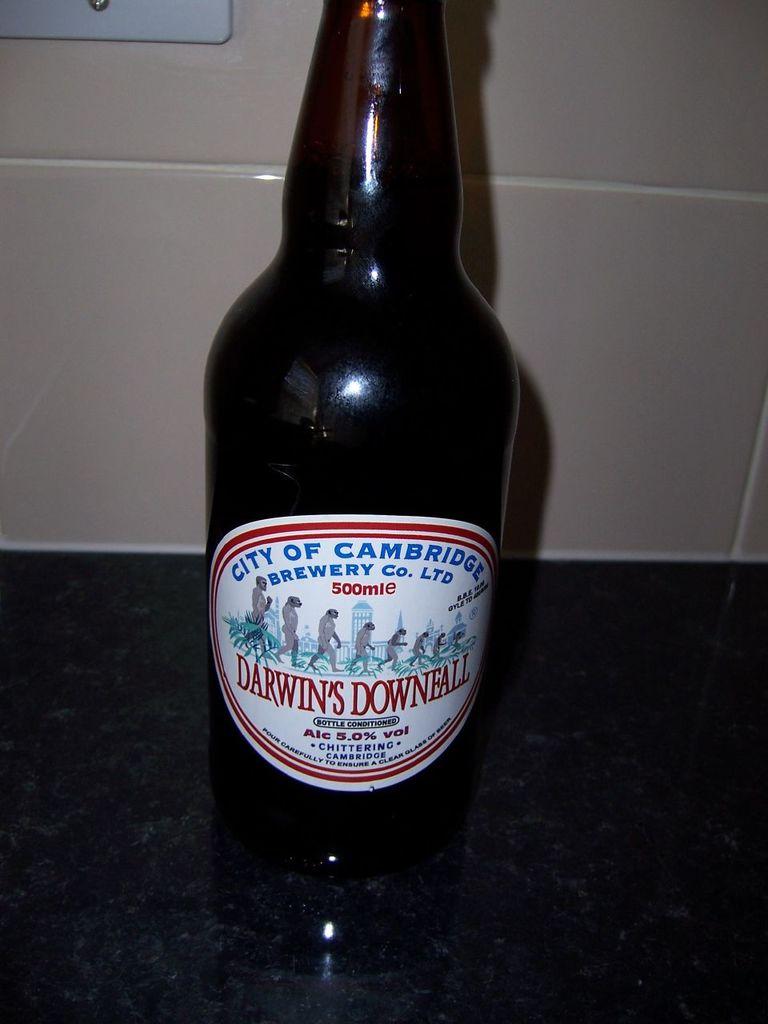What famous scientist is this beer named after?
Provide a short and direct response. Darwin. What is the name of the beer?
Your response must be concise. Darwin's downfall. 